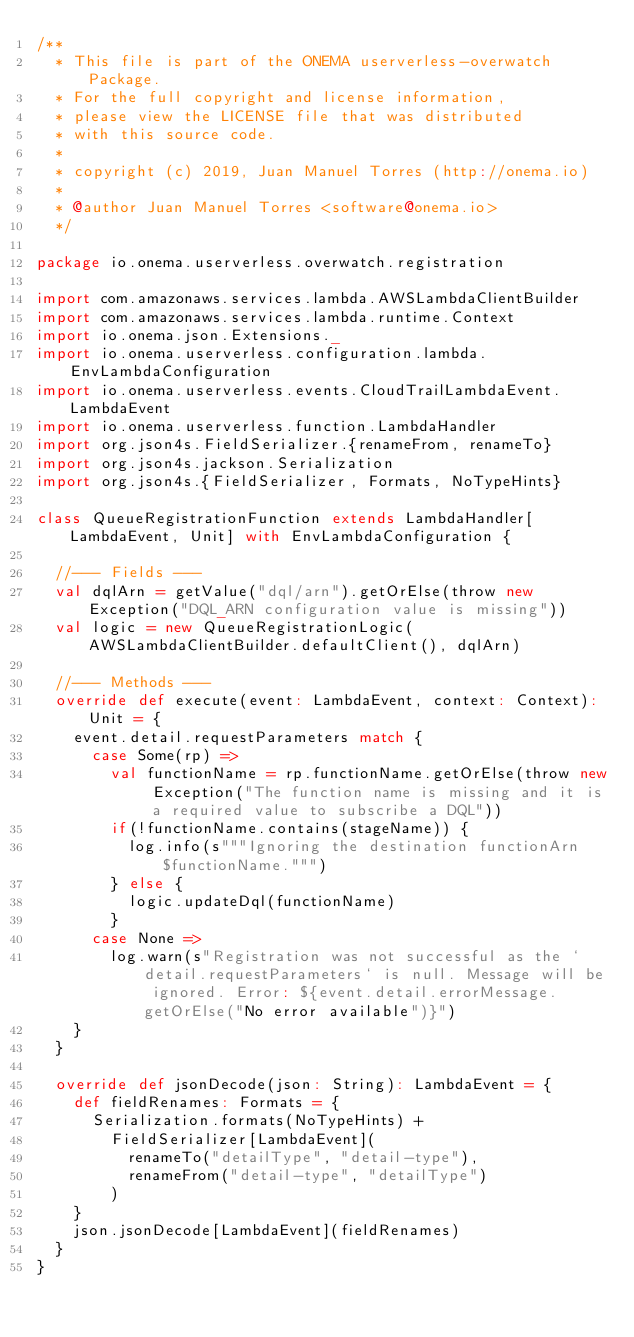Convert code to text. <code><loc_0><loc_0><loc_500><loc_500><_Scala_>/**
  * This file is part of the ONEMA userverless-overwatch Package.
  * For the full copyright and license information,
  * please view the LICENSE file that was distributed
  * with this source code.
  *
  * copyright (c) 2019, Juan Manuel Torres (http://onema.io)
  *
  * @author Juan Manuel Torres <software@onema.io>
  */

package io.onema.userverless.overwatch.registration

import com.amazonaws.services.lambda.AWSLambdaClientBuilder
import com.amazonaws.services.lambda.runtime.Context
import io.onema.json.Extensions._
import io.onema.userverless.configuration.lambda.EnvLambdaConfiguration
import io.onema.userverless.events.CloudTrailLambdaEvent.LambdaEvent
import io.onema.userverless.function.LambdaHandler
import org.json4s.FieldSerializer.{renameFrom, renameTo}
import org.json4s.jackson.Serialization
import org.json4s.{FieldSerializer, Formats, NoTypeHints}

class QueueRegistrationFunction extends LambdaHandler[LambdaEvent, Unit] with EnvLambdaConfiguration {

  //--- Fields ---
  val dqlArn = getValue("dql/arn").getOrElse(throw new Exception("DQL_ARN configuration value is missing"))
  val logic = new QueueRegistrationLogic(AWSLambdaClientBuilder.defaultClient(), dqlArn)

  //--- Methods ---
  override def execute(event: LambdaEvent, context: Context): Unit = {
    event.detail.requestParameters match {
      case Some(rp) =>
        val functionName = rp.functionName.getOrElse(throw new Exception("The function name is missing and it is a required value to subscribe a DQL"))
        if(!functionName.contains(stageName)) {
          log.info(s"""Ignoring the destination functionArn $functionName.""")
        } else {
          logic.updateDql(functionName)
        }
      case None =>
        log.warn(s"Registration was not successful as the `detail.requestParameters` is null. Message will be ignored. Error: ${event.detail.errorMessage.getOrElse("No error available")}")
    }
  }

  override def jsonDecode(json: String): LambdaEvent = {
    def fieldRenames: Formats = {
      Serialization.formats(NoTypeHints) +
        FieldSerializer[LambdaEvent](
          renameTo("detailType", "detail-type"),
          renameFrom("detail-type", "detailType")
        )
    }
    json.jsonDecode[LambdaEvent](fieldRenames)
  }
}
</code> 